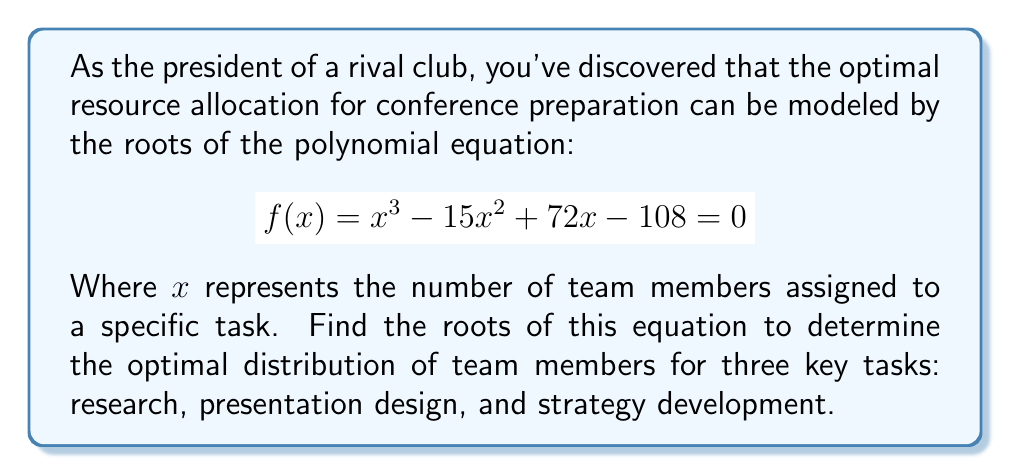What is the answer to this math problem? To solve this polynomial equation, we'll use the following steps:

1) First, let's check if there are any rational roots using the rational root theorem. The possible rational roots are the factors of the constant term (108): ±1, ±2, ±3, ±4, ±6, ±9, ±12, ±18, ±27, ±36, ±54, ±108.

2) Testing these values, we find that 3 is a root of the equation.

3) Now we can factor out $(x - 3)$:

   $f(x) = (x - 3)(x^2 - 12x + 36)$

4) The quadratic factor $x^2 - 12x + 36$ can be solved using the quadratic formula or by factoring:

   $x^2 - 12x + 36 = (x - 6)(x - 6)$

5) Therefore, the complete factorization is:

   $f(x) = (x - 3)(x - 6)(x - 6)$

6) The roots of the equation are $x = 3$ and $x = 6$ (with multiplicity 2).

These roots represent the optimal number of team members to assign to each task:
- 3 members for research
- 6 members for presentation design
- 6 members for strategy development
Answer: The roots of the equation are $x = 3$ and $x = 6$ (with multiplicity 2). 